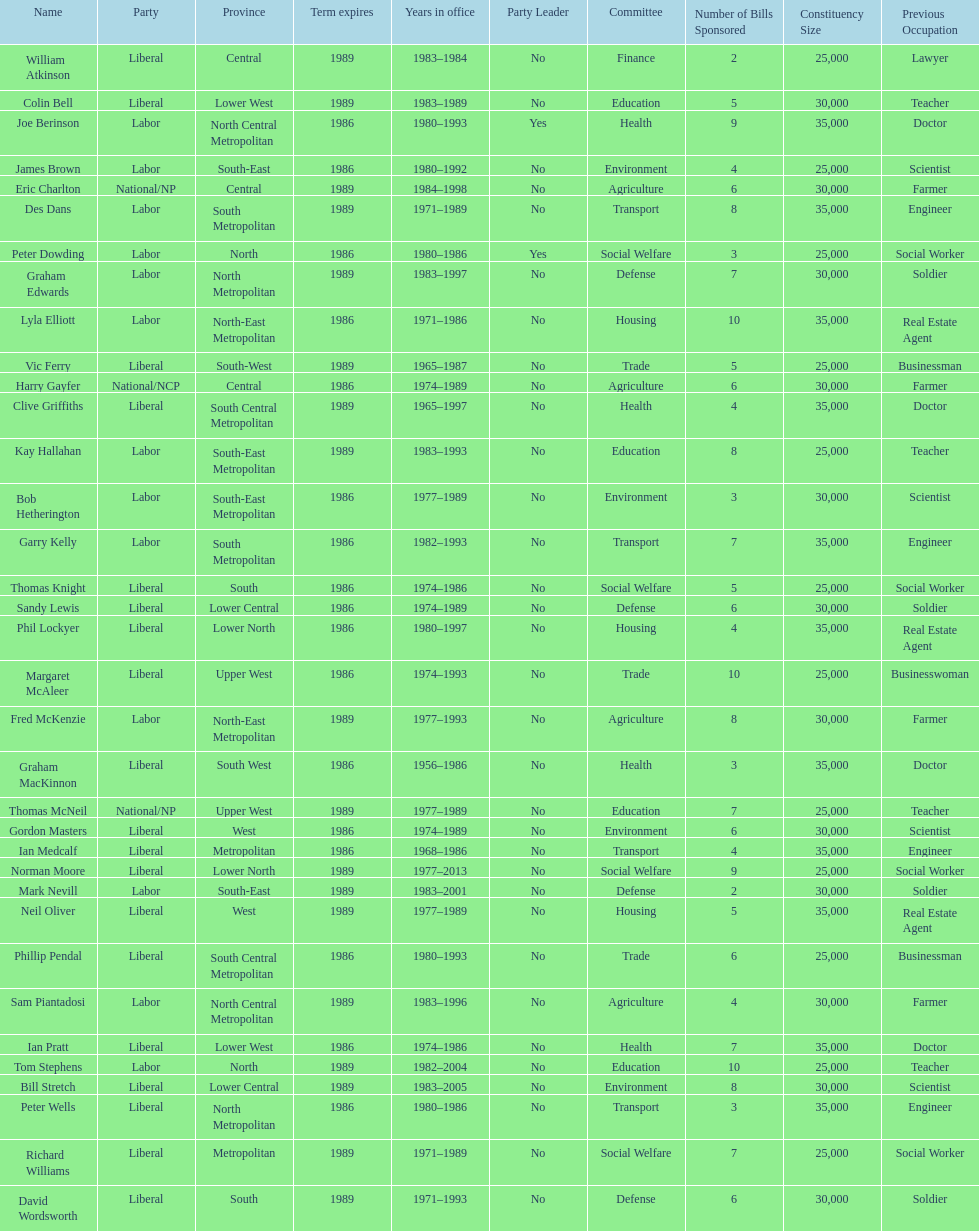Who has had the shortest term in office William Atkinson. 